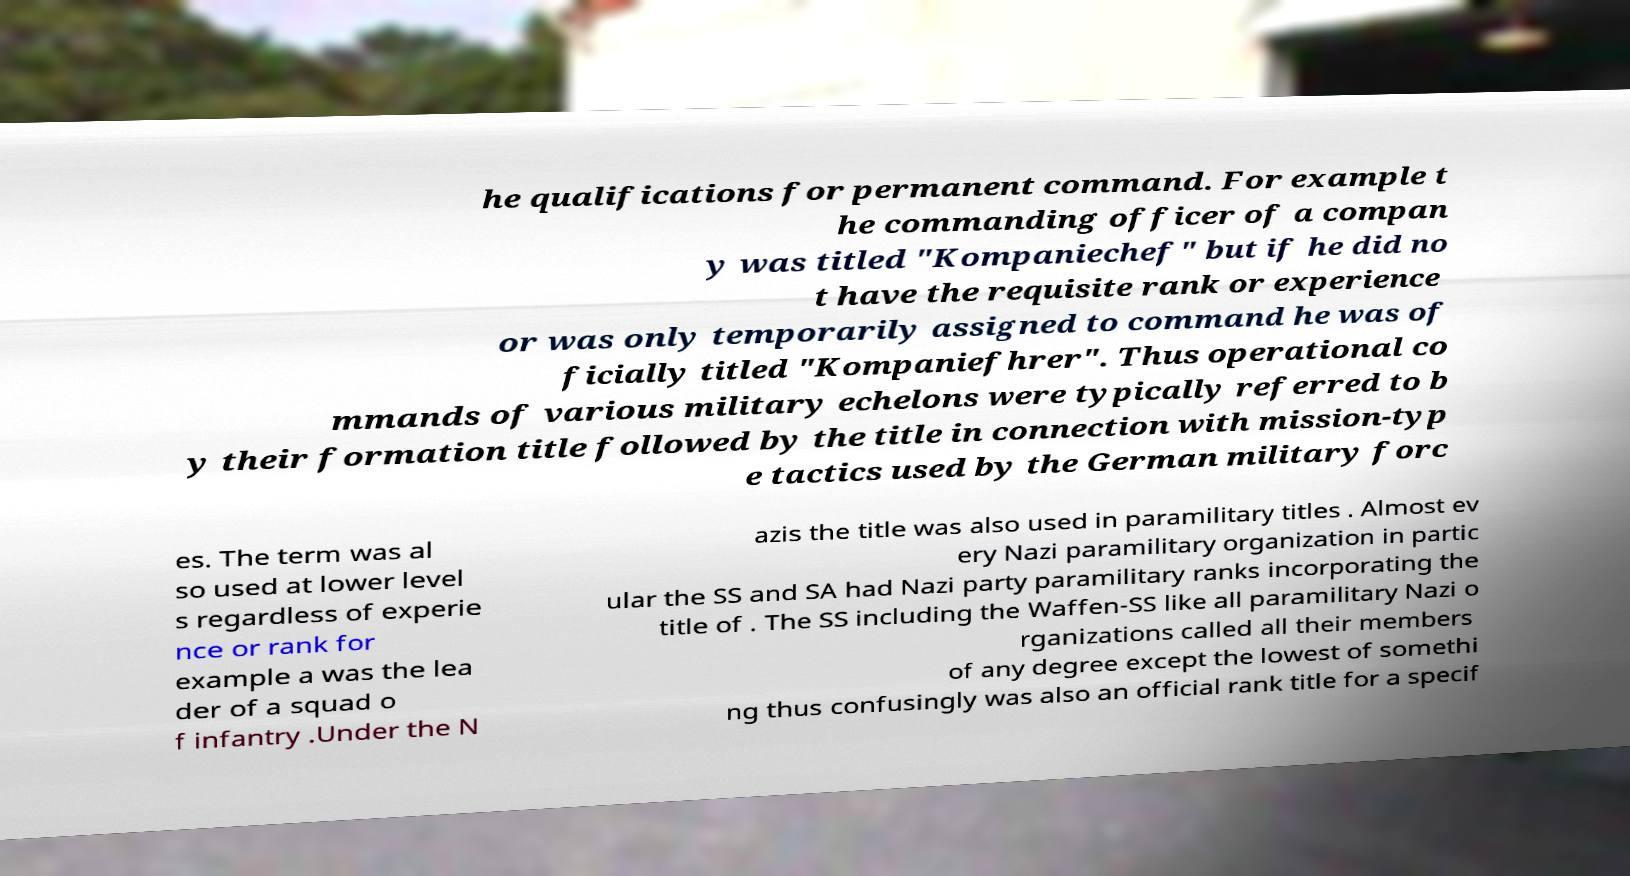Can you accurately transcribe the text from the provided image for me? he qualifications for permanent command. For example t he commanding officer of a compan y was titled "Kompaniechef" but if he did no t have the requisite rank or experience or was only temporarily assigned to command he was of ficially titled "Kompaniefhrer". Thus operational co mmands of various military echelons were typically referred to b y their formation title followed by the title in connection with mission-typ e tactics used by the German military forc es. The term was al so used at lower level s regardless of experie nce or rank for example a was the lea der of a squad o f infantry .Under the N azis the title was also used in paramilitary titles . Almost ev ery Nazi paramilitary organization in partic ular the SS and SA had Nazi party paramilitary ranks incorporating the title of . The SS including the Waffen-SS like all paramilitary Nazi o rganizations called all their members of any degree except the lowest of somethi ng thus confusingly was also an official rank title for a specif 